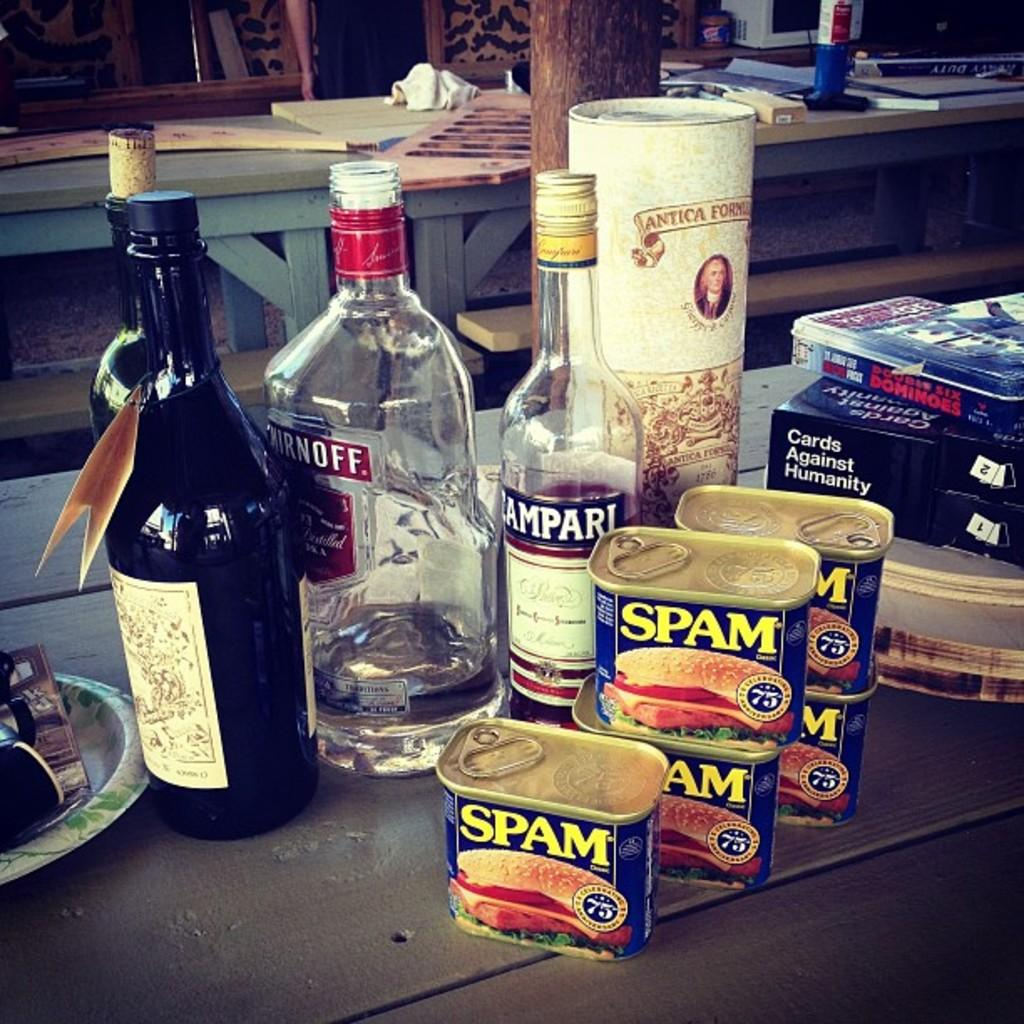What objects are on the table in the image? There is a group of bottles on a table in the image. What can be seen in the background of the image? There are tables and a bench in the background of the image. What month is it in the image? The month cannot be determined from the image, as there is no information about the time or date. 